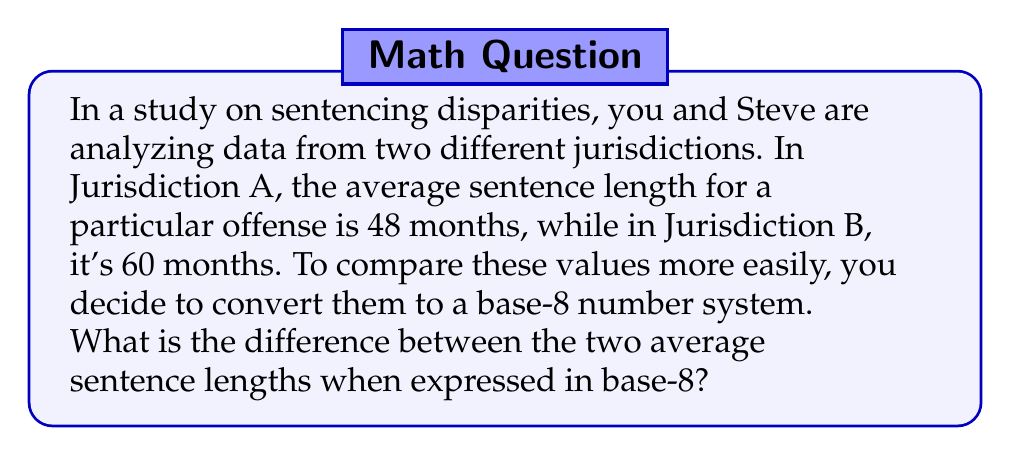What is the answer to this math problem? To solve this problem, we need to follow these steps:

1) First, let's convert 48 months (Jurisdiction A) to base-8:
   
   $48_{10} = ?_8$
   
   We divide 48 by 8 repeatedly and keep track of the remainders:
   
   $48 \div 8 = 6$ remainder $0$
   $6 \div 8 = 0$ remainder $6$
   
   Reading the remainders from bottom to top, we get:
   
   $48_{10} = 60_8$

2) Now, let's convert 60 months (Jurisdiction B) to base-8:
   
   $60_{10} = ?_8$
   
   $60 \div 8 = 7$ remainder $4$
   $7 \div 8 = 0$ remainder $7$
   
   Therefore:
   
   $60_{10} = 74_8$

3) Now we can subtract the base-8 numbers:

   $$74_8 - 60_8 = 14_8$$

4) To verify, we can convert $14_8$ back to base-10:

   $14_8 = (1 \times 8^1) + (4 \times 8^0) = 8 + 4 = 12_{10}$

   This makes sense, as $60 - 48 = 12$ in base-10.
Answer: $14_8$ 